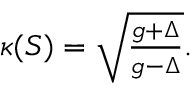Convert formula to latex. <formula><loc_0><loc_0><loc_500><loc_500>\begin{array} { r } { \kappa ( S ) = \sqrt { \frac { g + \Delta } { g - \Delta } } . } \end{array}</formula> 